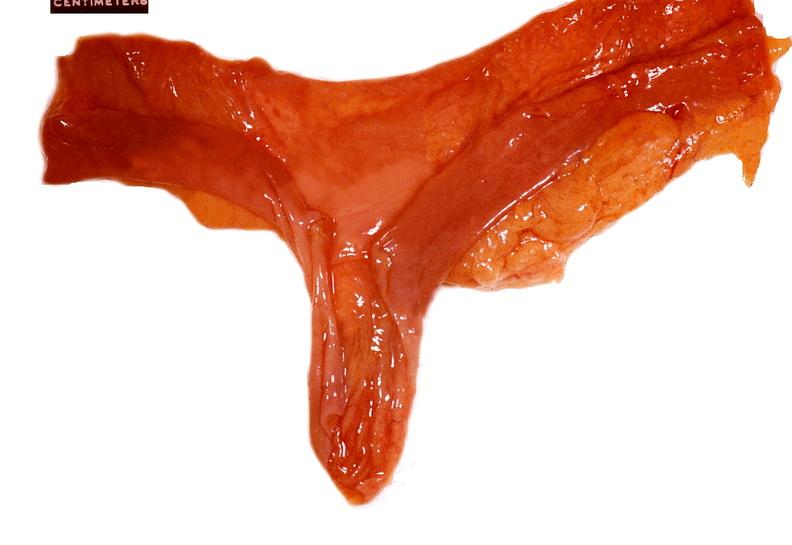s lymphangiomatosis generalized present?
Answer the question using a single word or phrase. No 